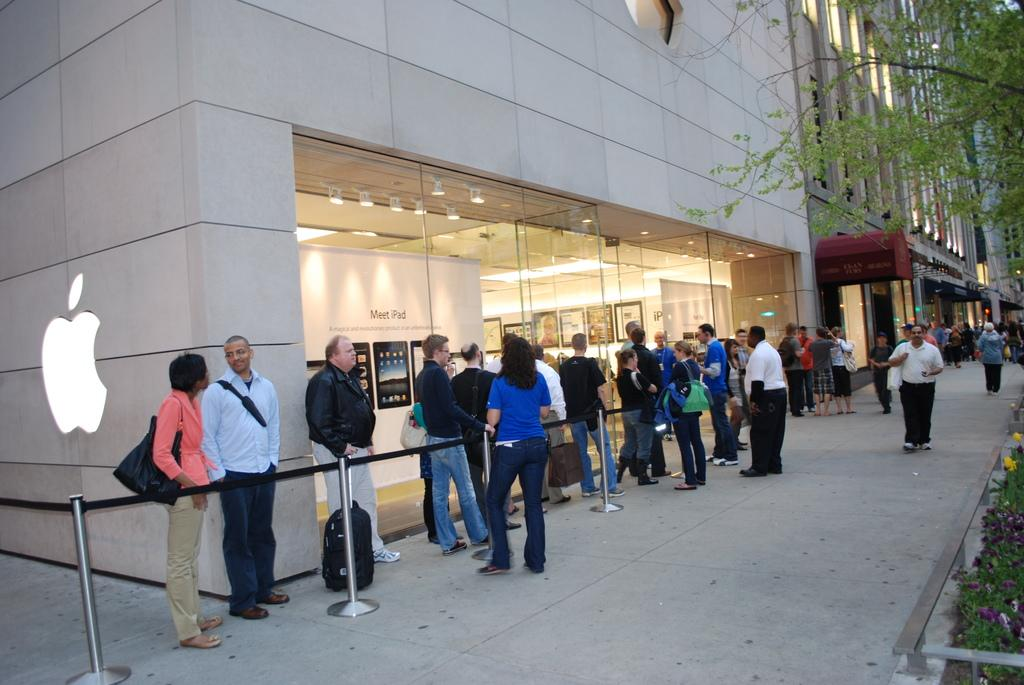Who or what can be seen in the image? There are people in the image. What structures are visible in the image? There are buildings in the image. What type of plant is present in the image? There is a tree in the image. Can you see any kites flying in the image? There is no kite visible in the image. Do the people in the image have fangs? There is no indication of fangs on the people in the image. 